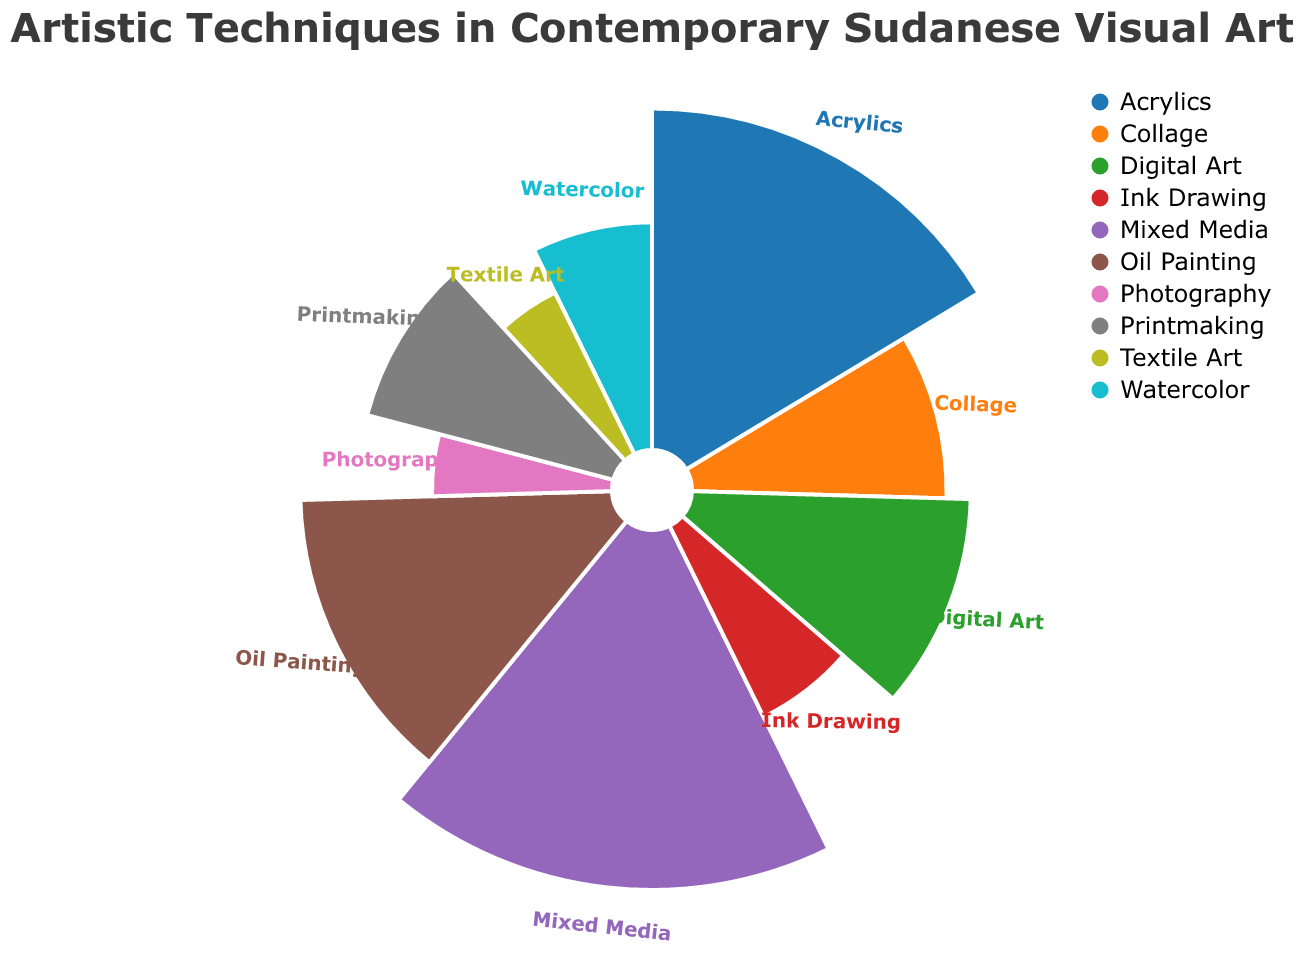What's the title of the figure? The title of the figure is located at the top and typically explains the subject of the chart. From the data provided, the title is: "Artistic Techniques in Contemporary Sudanese Visual Art"
Answer: Artistic Techniques in Contemporary Sudanese Visual Art How many different artistic techniques are represented in the chart? By counting the number of unique entries in the 'Technique' field, we see there are ten different artistic techniques represented.
Answer: 10 Which technique has the highest proportion? Observing the proportions for all techniques, "Mixed Media" has the largest slice with 20%.
Answer: Mixed Media What is the combined proportion of "Photography" and "Textile Art"? Adding the proportions of "Photography" (5%) and "Textile Art" (5%) gives a total of 10%.
Answer: 10% Which techniques have the same proportion? By comparing the proportions, "Photography" and "Textile Art" both have a proportion of 5%.
Answer: Photography, Textile Art What is the difference in proportion between "Mixed Media" and "Watercolor"? Subtracting the proportion of "Watercolor" (8%) from "Mixed Media" (20%) gives a difference of 12%.
Answer: 12% Rank the techniques from highest to lowest proportion. Ordering the techniques from the highest to the lowest proportion gives: "Mixed Media" (20%), "Acrylics" (18%), "Oil Painting" (15%), "Digital Art" (12%), "Collage" and "Printmaking" (10% each), "Watercolor" (8%), "Ink Drawing" (7%), "Photography" and "Textile Art" (5% each).
Answer: Mixed Media, Acrylics, Oil Painting, Digital Art, Collage, Printmaking, Watercolor, Ink Drawing, Photography, Textile Art Which technique has the smallest proportion? "Textile Art" and "Photography" both have the smallest proportions at 5%.
Answer: Textile Art, Photography What's the average proportion for "Oil Painting," "Acrylics," and "Printmaking"? Adding the proportions (15% + 18% + 10%) and dividing by the number of techniques (3) gives an average of 43% / 3 = 14.33%.
Answer: 14.33% What is the total proportion of "Digital Art" and "Collage" compared to "Oil Painting"? Adding the proportions of "Digital Art" (12%) and "Collage" (10%) gives 22%, compared to 15% for "Oil Painting".
Answer: 22% vs 15% 